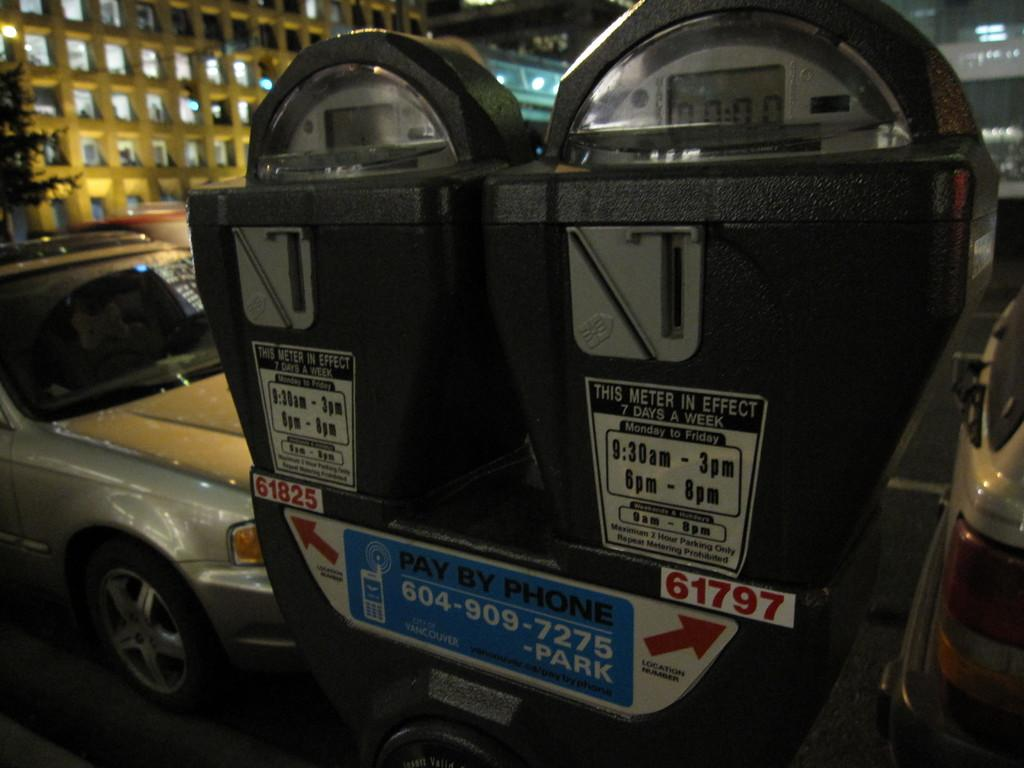Provide a one-sentence caption for the provided image. Two parking meters in front of a parked car that are in effect 7 days a week. 